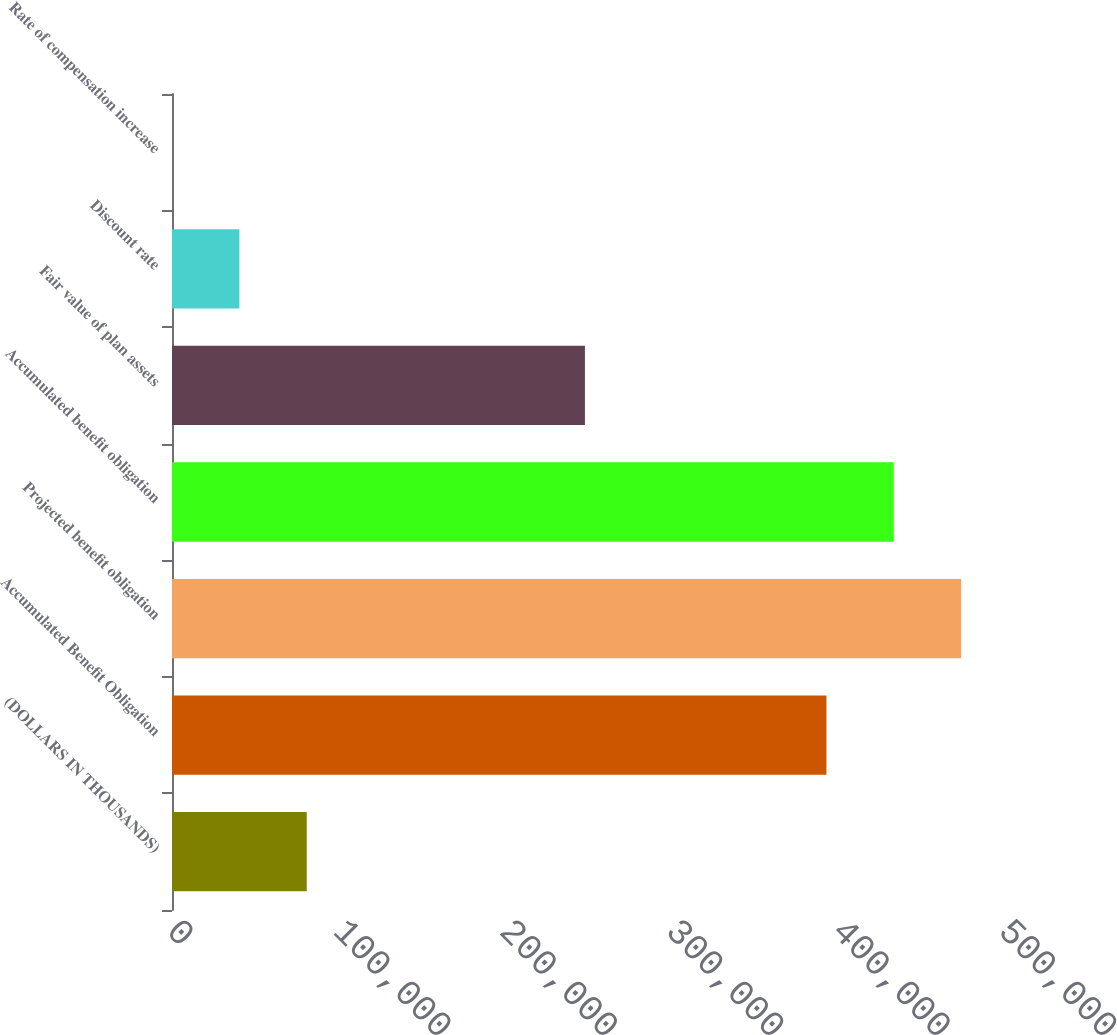Convert chart. <chart><loc_0><loc_0><loc_500><loc_500><bar_chart><fcel>(DOLLARS IN THOUSANDS)<fcel>Accumulated Benefit Obligation<fcel>Projected benefit obligation<fcel>Accumulated benefit obligation<fcel>Fair value of plan assets<fcel>Discount rate<fcel>Rate of compensation increase<nl><fcel>80983.2<fcel>393284<fcel>474264<fcel>433774<fcel>248151<fcel>40493.3<fcel>3.5<nl></chart> 